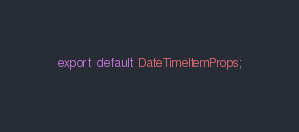Convert code to text. <code><loc_0><loc_0><loc_500><loc_500><_TypeScript_>
export default DateTimeItemProps;</code> 